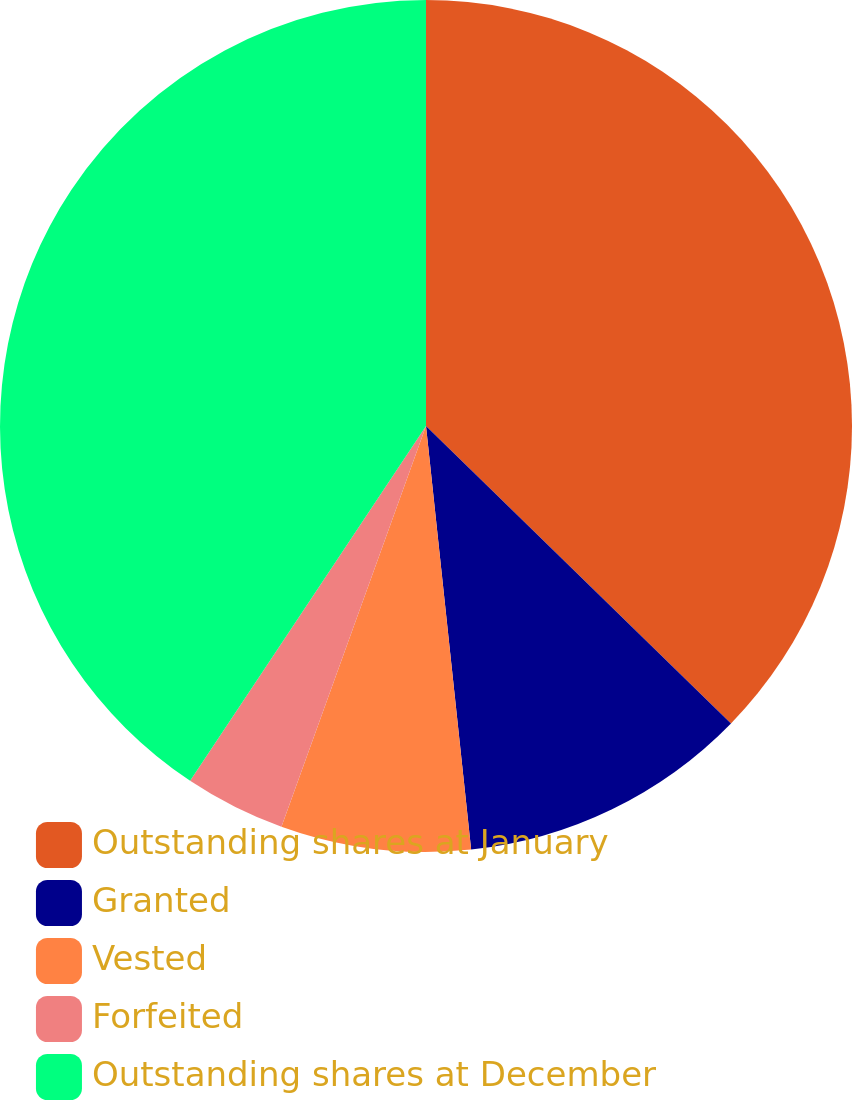Convert chart. <chart><loc_0><loc_0><loc_500><loc_500><pie_chart><fcel>Outstanding shares at January<fcel>Granted<fcel>Vested<fcel>Forfeited<fcel>Outstanding shares at December<nl><fcel>37.3%<fcel>11.01%<fcel>7.2%<fcel>3.83%<fcel>40.66%<nl></chart> 